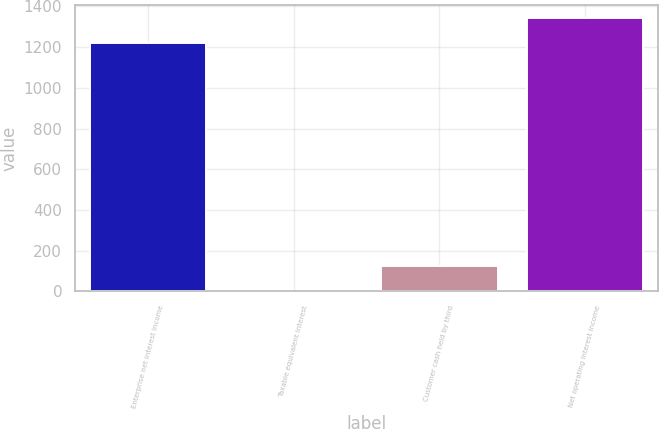Convert chart to OTSL. <chart><loc_0><loc_0><loc_500><loc_500><bar_chart><fcel>Enterprise net interest income<fcel>Taxable equivalent interest<fcel>Customer cash held by third<fcel>Net operating interest income<nl><fcel>1219.1<fcel>1.2<fcel>123.71<fcel>1341.61<nl></chart> 